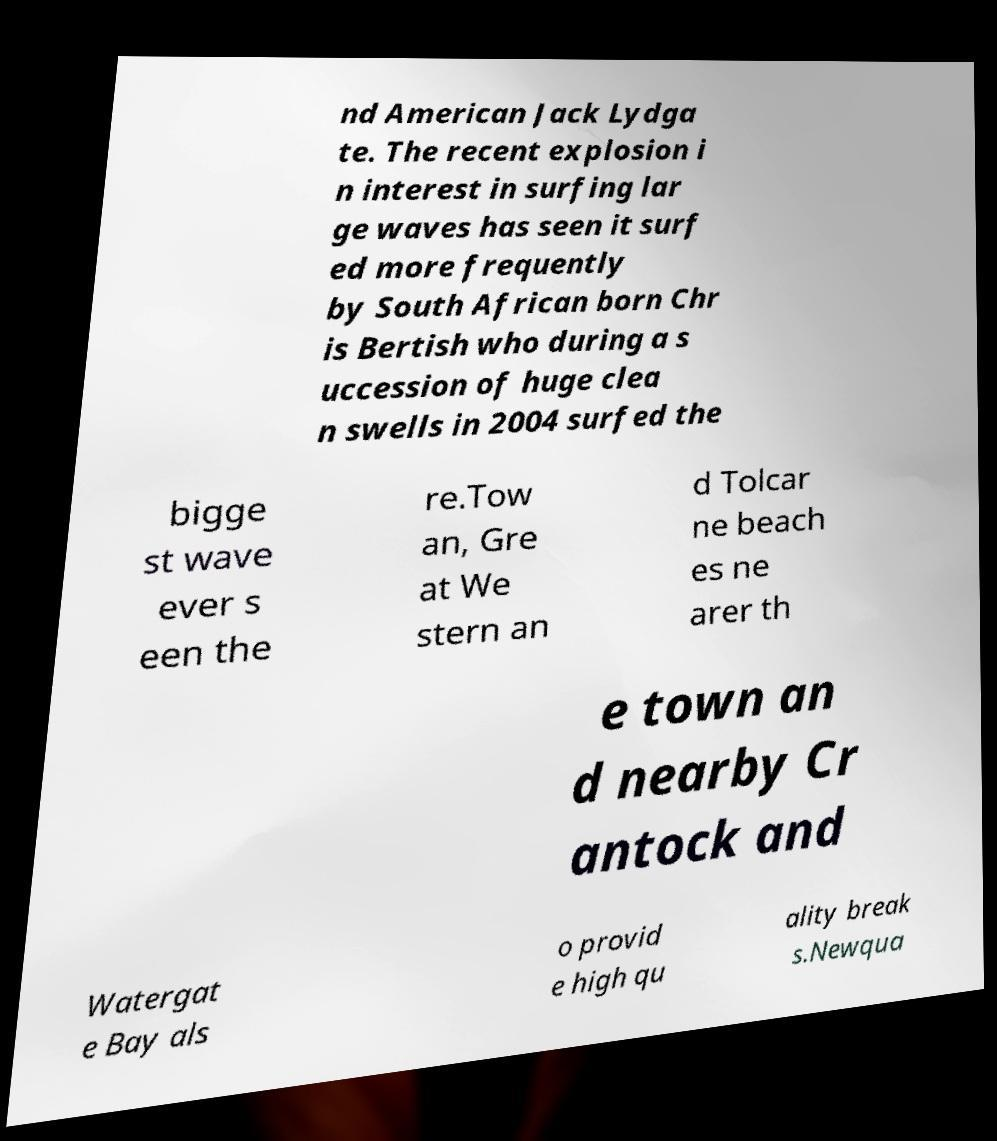Can you accurately transcribe the text from the provided image for me? nd American Jack Lydga te. The recent explosion i n interest in surfing lar ge waves has seen it surf ed more frequently by South African born Chr is Bertish who during a s uccession of huge clea n swells in 2004 surfed the bigge st wave ever s een the re.Tow an, Gre at We stern an d Tolcar ne beach es ne arer th e town an d nearby Cr antock and Watergat e Bay als o provid e high qu ality break s.Newqua 